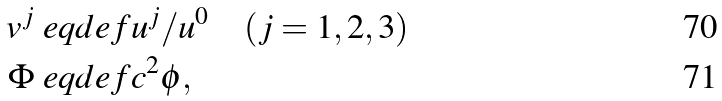Convert formula to latex. <formula><loc_0><loc_0><loc_500><loc_500>v ^ { j } & \ e q d e f { u ^ { j } } / { u ^ { 0 } } \quad ( j = 1 , 2 , 3 ) \\ \Phi & \ e q d e f c ^ { 2 } \phi ,</formula> 